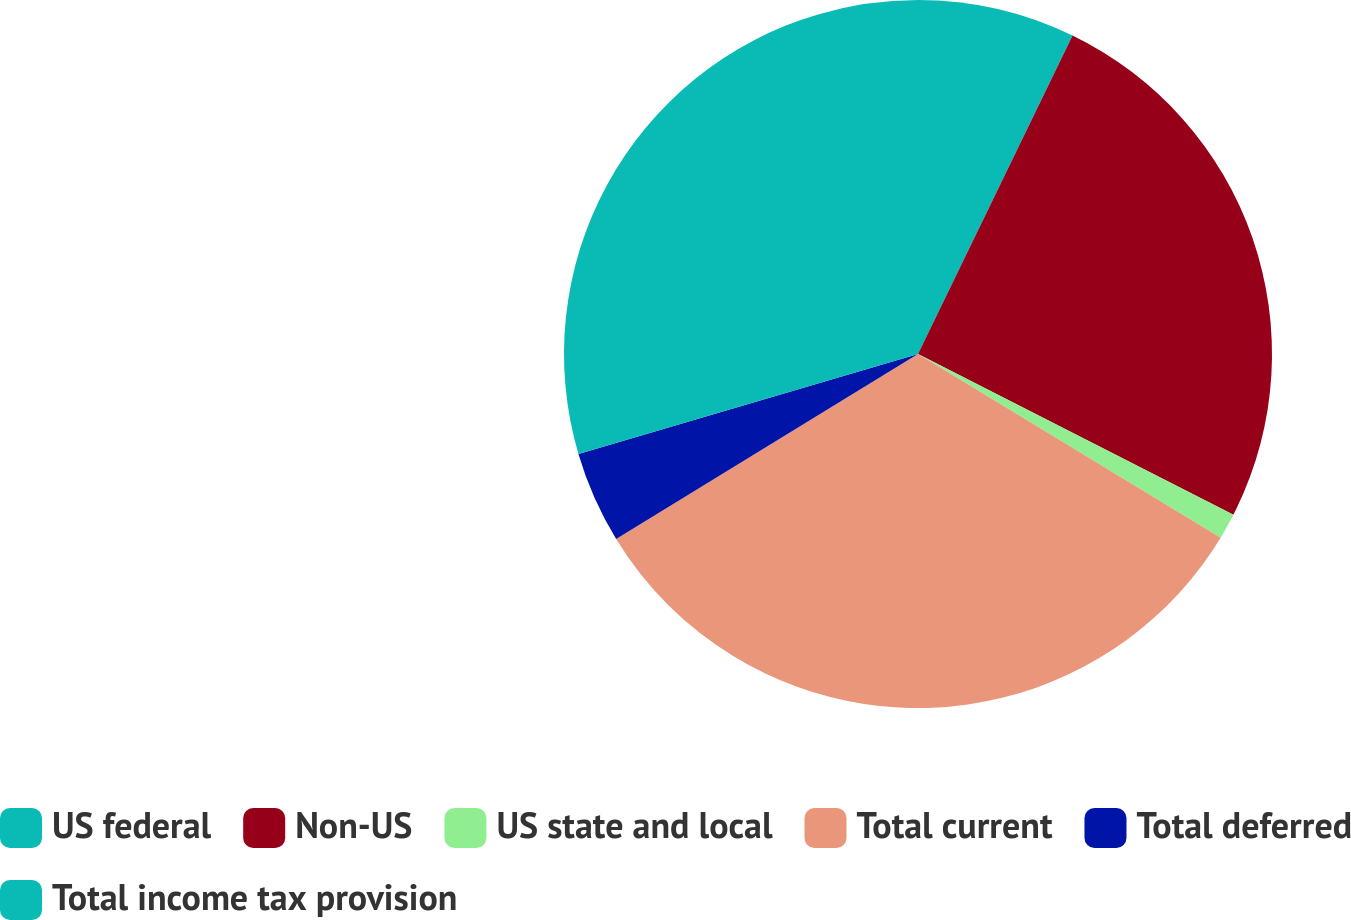Convert chart to OTSL. <chart><loc_0><loc_0><loc_500><loc_500><pie_chart><fcel>US federal<fcel>Non-US<fcel>US state and local<fcel>Total current<fcel>Total deferred<fcel>Total income tax provision<nl><fcel>7.19%<fcel>25.31%<fcel>1.18%<fcel>32.57%<fcel>4.19%<fcel>29.56%<nl></chart> 